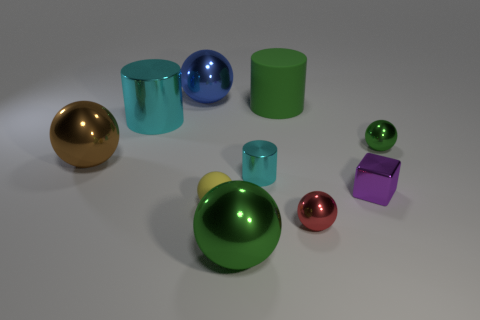Subtract all large green cylinders. How many cylinders are left? 2 Subtract all cylinders. How many objects are left? 7 Subtract all green cylinders. How many cylinders are left? 2 Subtract 0 cyan cubes. How many objects are left? 10 Subtract 2 cylinders. How many cylinders are left? 1 Subtract all gray cylinders. Subtract all yellow blocks. How many cylinders are left? 3 Subtract all green cylinders. How many brown blocks are left? 0 Subtract all small yellow metal cylinders. Subtract all purple blocks. How many objects are left? 9 Add 6 purple metallic things. How many purple metallic things are left? 7 Add 8 gray matte cubes. How many gray matte cubes exist? 8 